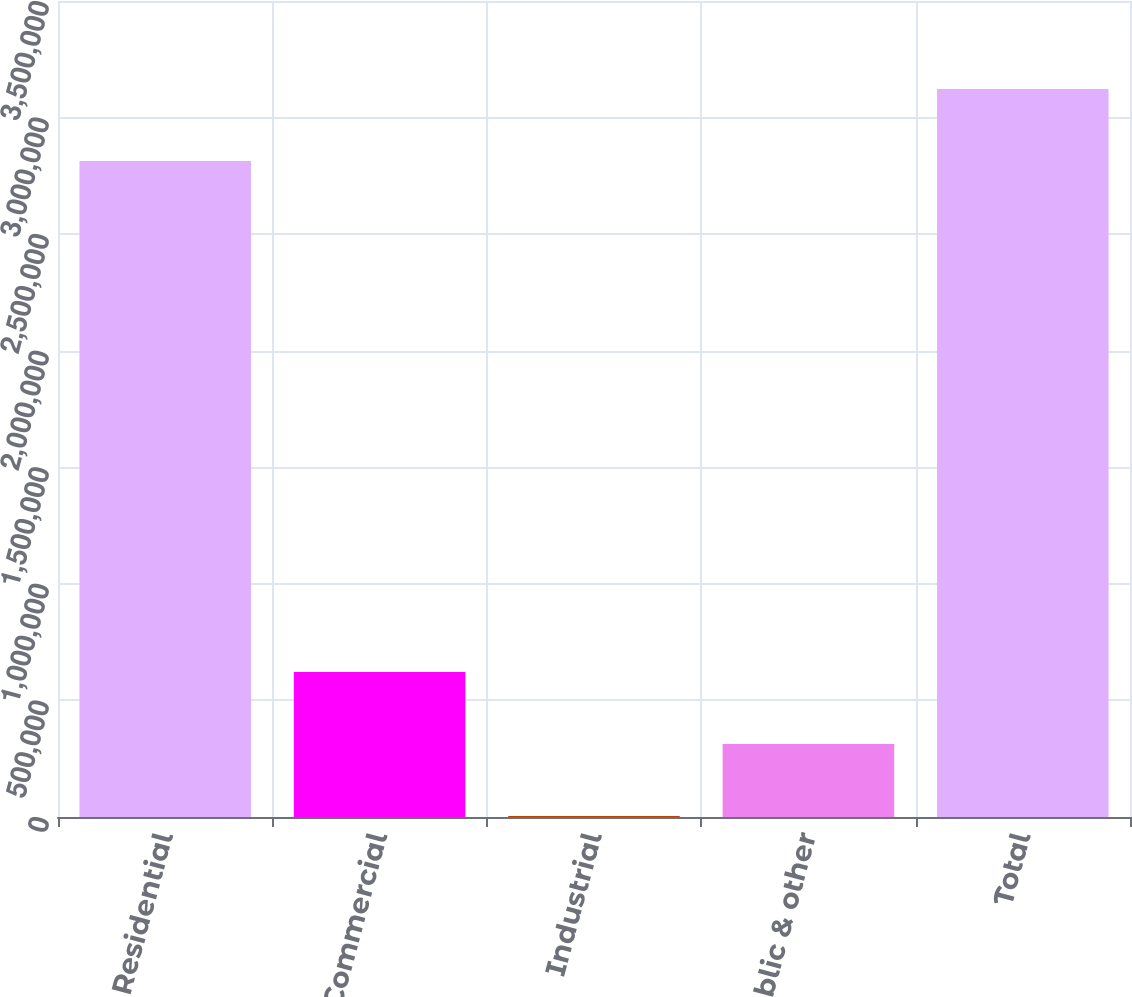Convert chart to OTSL. <chart><loc_0><loc_0><loc_500><loc_500><bar_chart><fcel>Residential<fcel>Commercial<fcel>Industrial<fcel>Public & other<fcel>Total<nl><fcel>2.8136e+06<fcel>622128<fcel>3822<fcel>312975<fcel>3.12275e+06<nl></chart> 